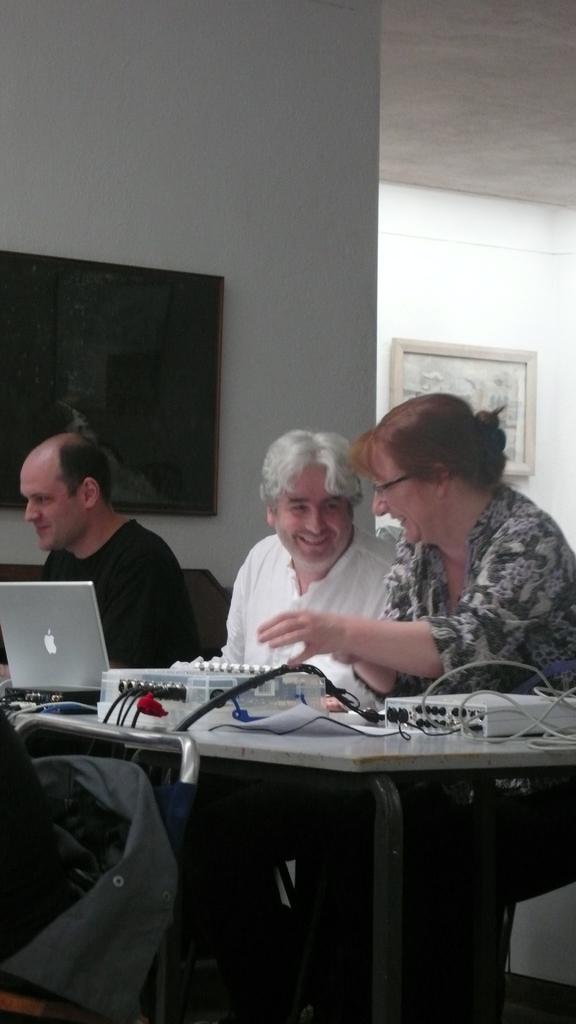Could you give a brief overview of what you see in this image? In this picture we can see three persons are sitting on chairs in front of a table, there is a laptop, a plastic box and an electronic thing present on the table, at the left bottom there is a chair, we can see a cloth on the chair, in the background we can see a wall, there is a photo frame on the wall, it looks like a screen on the left side. 